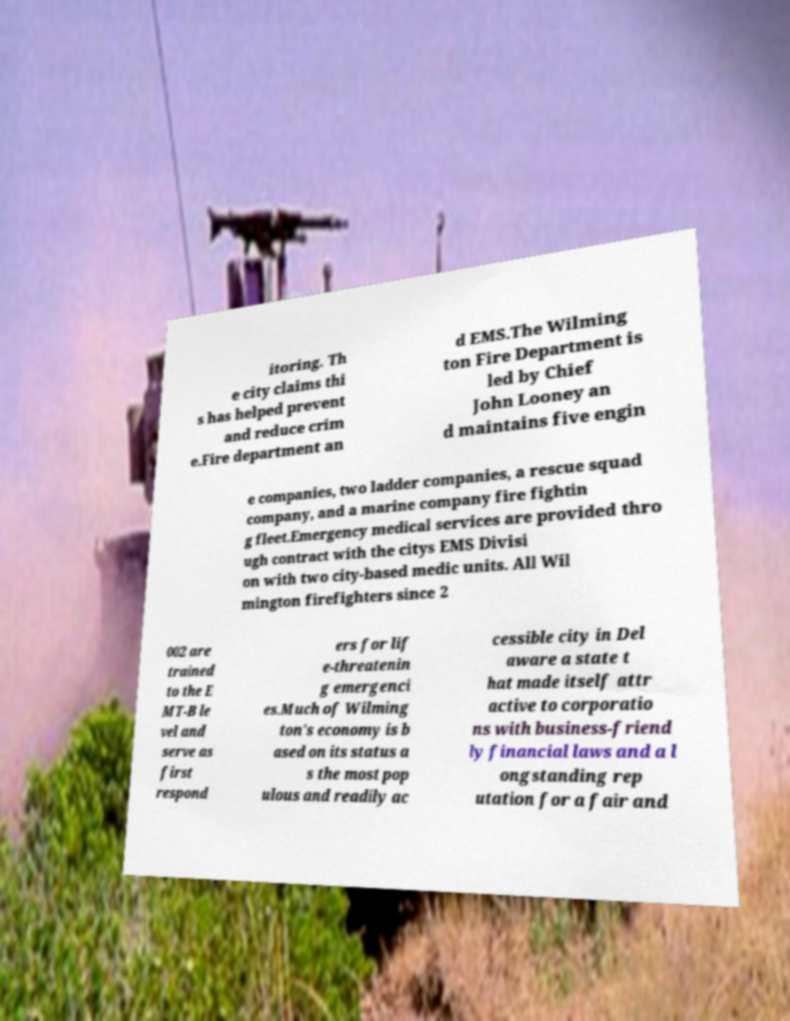Can you read and provide the text displayed in the image?This photo seems to have some interesting text. Can you extract and type it out for me? itoring. Th e city claims thi s has helped prevent and reduce crim e.Fire department an d EMS.The Wilming ton Fire Department is led by Chief John Looney an d maintains five engin e companies, two ladder companies, a rescue squad company, and a marine company fire fightin g fleet.Emergency medical services are provided thro ugh contract with the citys EMS Divisi on with two city-based medic units. All Wil mington firefighters since 2 002 are trained to the E MT-B le vel and serve as first respond ers for lif e-threatenin g emergenci es.Much of Wilming ton's economy is b ased on its status a s the most pop ulous and readily ac cessible city in Del aware a state t hat made itself attr active to corporatio ns with business-friend ly financial laws and a l ongstanding rep utation for a fair and 